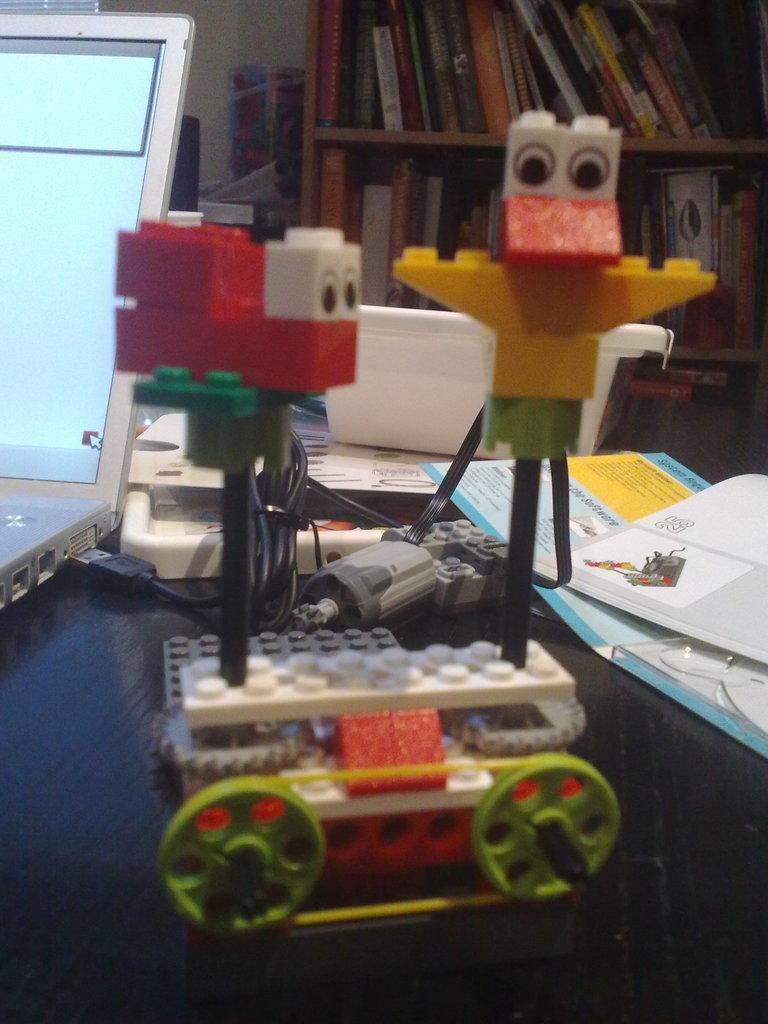Can you describe this image briefly? This picture is clicked inside. In the center there is a table on the top of which a laptop, box, toys, papers and some other items are placed. In the background there is a wooden cabinet containing many number of books and we can see there are some other objects. 